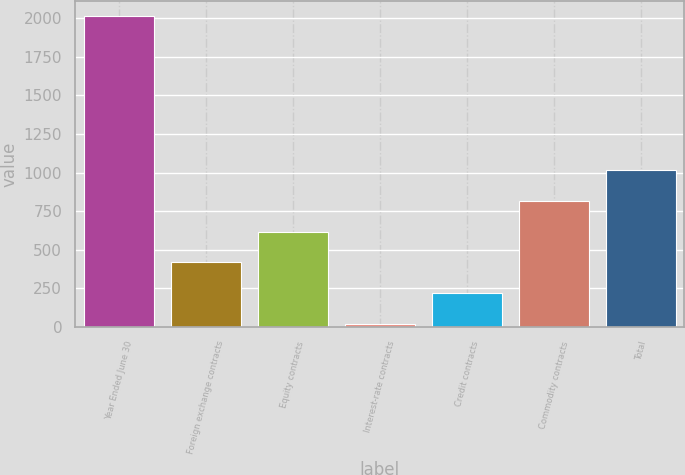<chart> <loc_0><loc_0><loc_500><loc_500><bar_chart><fcel>Year Ended June 30<fcel>Foreign exchange contracts<fcel>Equity contracts<fcel>Interest-rate contracts<fcel>Credit contracts<fcel>Commodity contracts<fcel>Total<nl><fcel>2011<fcel>417.4<fcel>616.6<fcel>19<fcel>218.2<fcel>815.8<fcel>1015<nl></chart> 